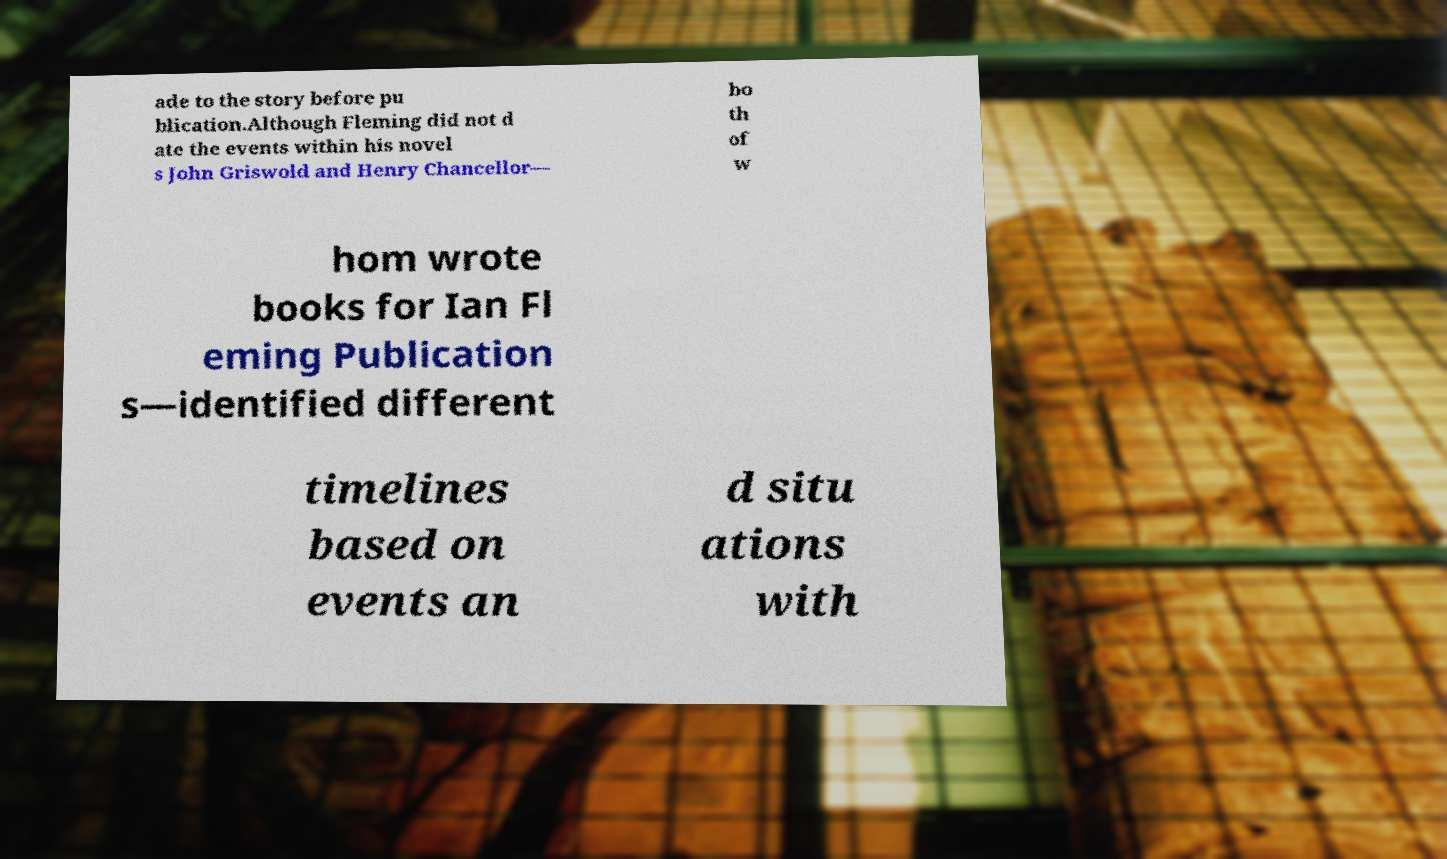I need the written content from this picture converted into text. Can you do that? ade to the story before pu blication.Although Fleming did not d ate the events within his novel s John Griswold and Henry Chancellor— bo th of w hom wrote books for Ian Fl eming Publication s—identified different timelines based on events an d situ ations with 